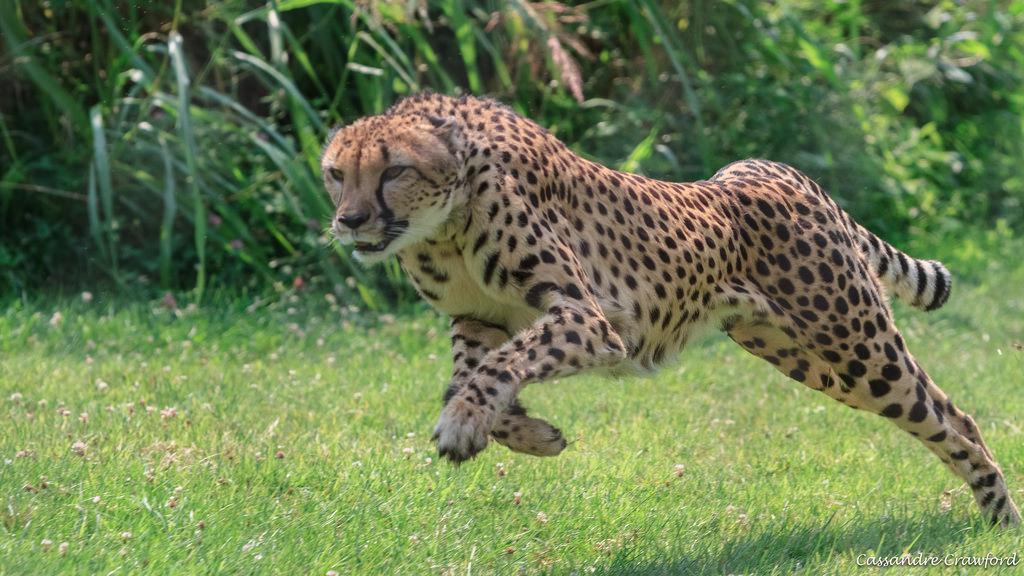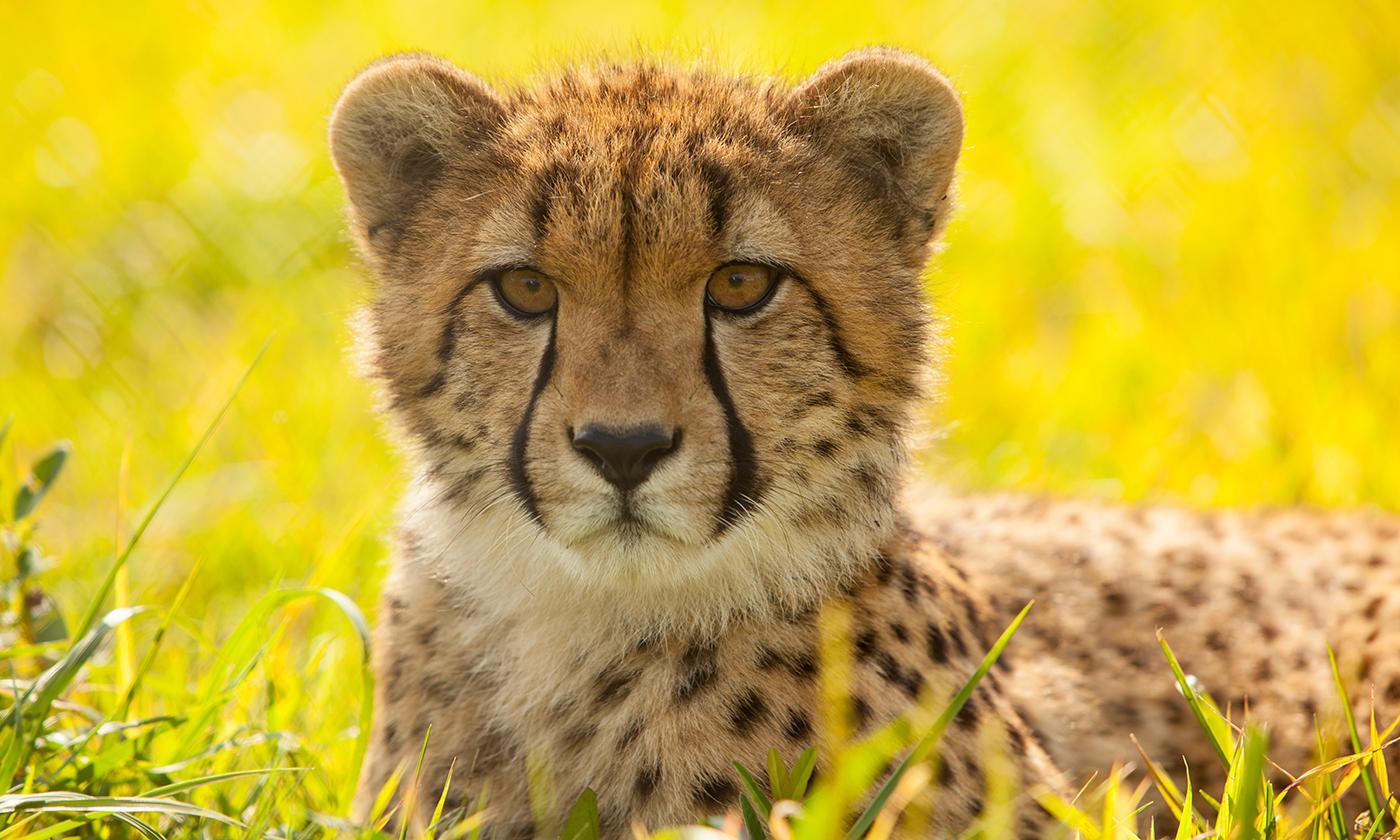The first image is the image on the left, the second image is the image on the right. Examine the images to the left and right. Is the description "The cheetah on the right image is a close up of its face while looking at the camera." accurate? Answer yes or no. Yes. 